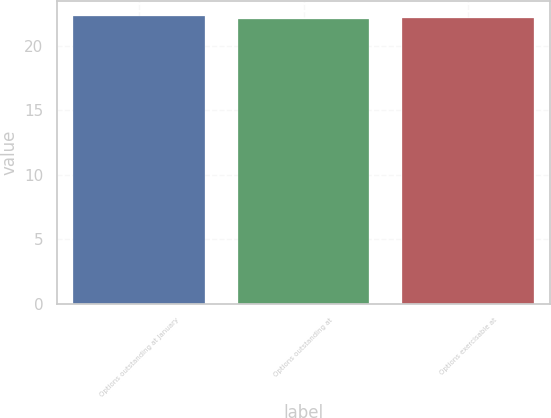Convert chart. <chart><loc_0><loc_0><loc_500><loc_500><bar_chart><fcel>Options outstanding at January<fcel>Options outstanding at<fcel>Options exercisable at<nl><fcel>22.35<fcel>22.12<fcel>22.18<nl></chart> 